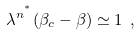<formula> <loc_0><loc_0><loc_500><loc_500>\lambda ^ { n ^ { ^ { * } } } ( \beta _ { c } - \beta ) \simeq 1 \ ,</formula> 